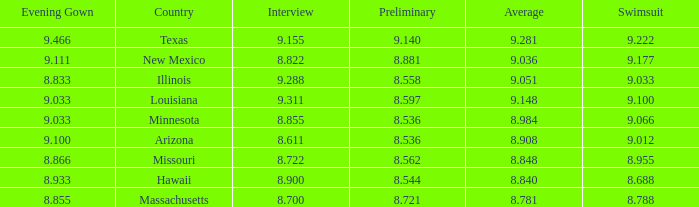What was the swimsuit score for the country with the average score of 8.848? 8.955. 